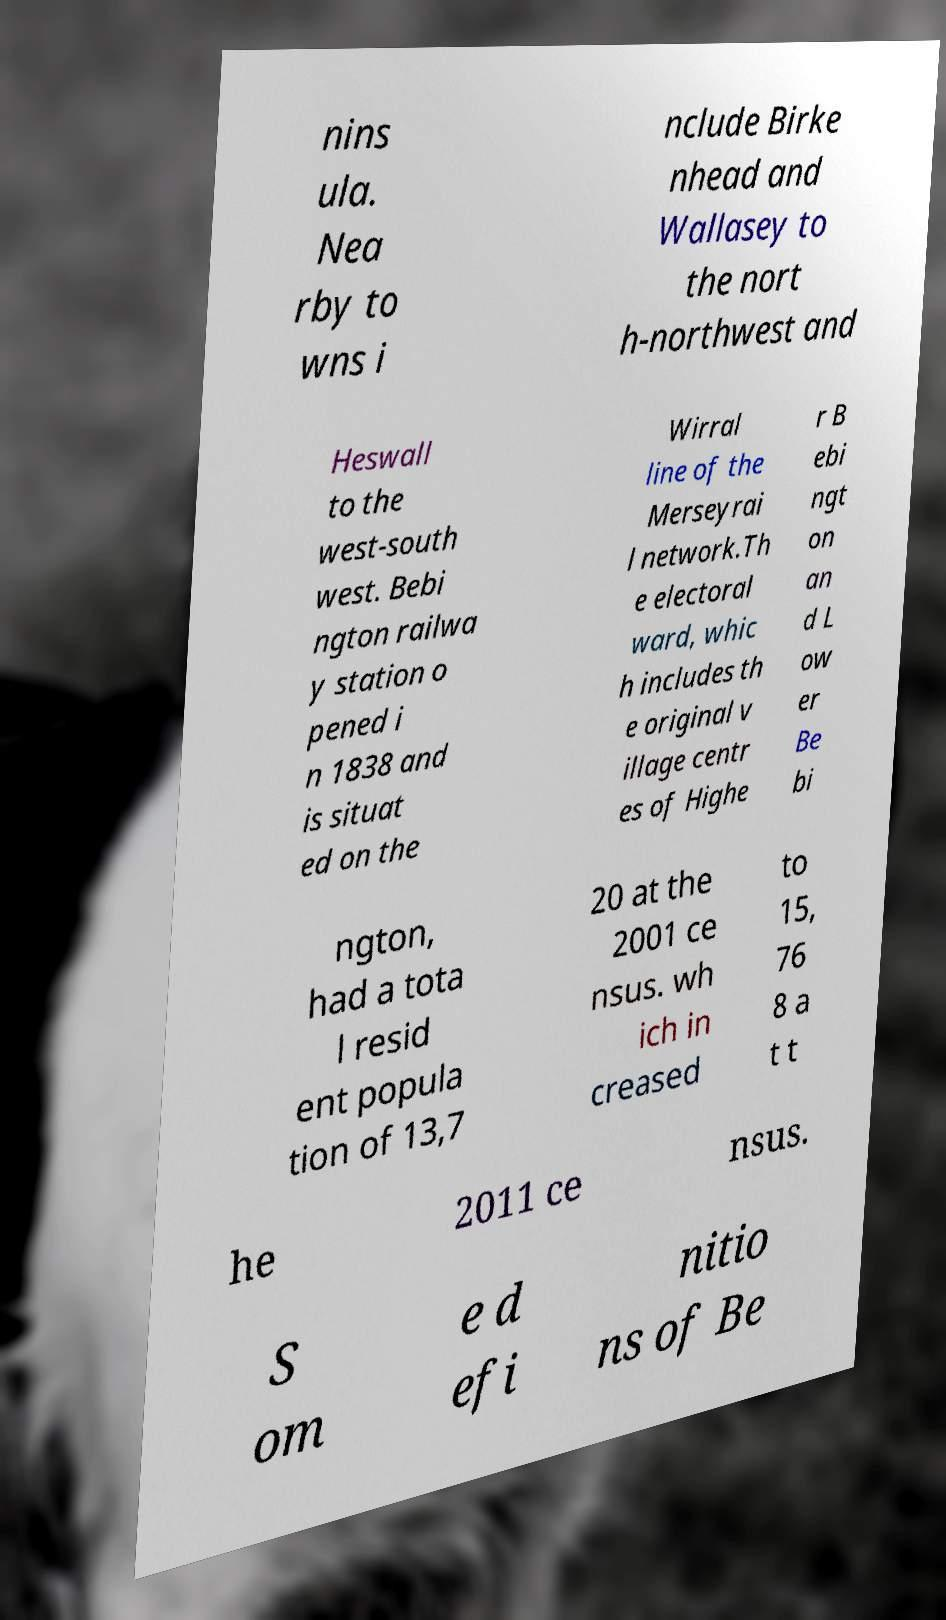Please identify and transcribe the text found in this image. nins ula. Nea rby to wns i nclude Birke nhead and Wallasey to the nort h-northwest and Heswall to the west-south west. Bebi ngton railwa y station o pened i n 1838 and is situat ed on the Wirral line of the Merseyrai l network.Th e electoral ward, whic h includes th e original v illage centr es of Highe r B ebi ngt on an d L ow er Be bi ngton, had a tota l resid ent popula tion of 13,7 20 at the 2001 ce nsus. wh ich in creased to 15, 76 8 a t t he 2011 ce nsus. S om e d efi nitio ns of Be 